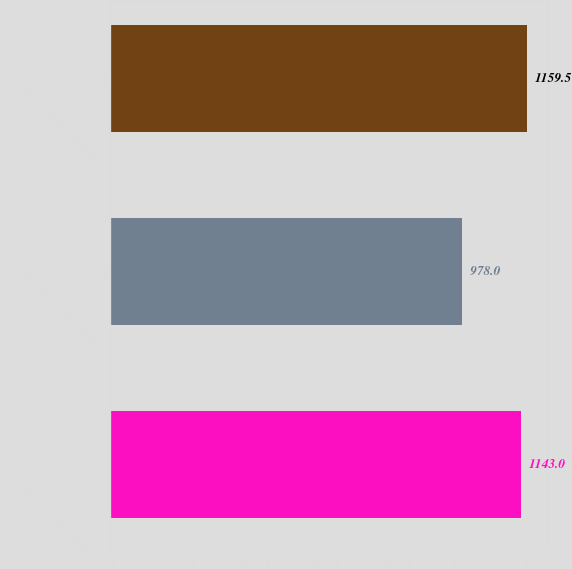Convert chart. <chart><loc_0><loc_0><loc_500><loc_500><bar_chart><fcel>Accumulated benefit obligation<fcel>Fair value of plan assets<fcel>Projected benefit obligation<nl><fcel>1143<fcel>978<fcel>1159.5<nl></chart> 